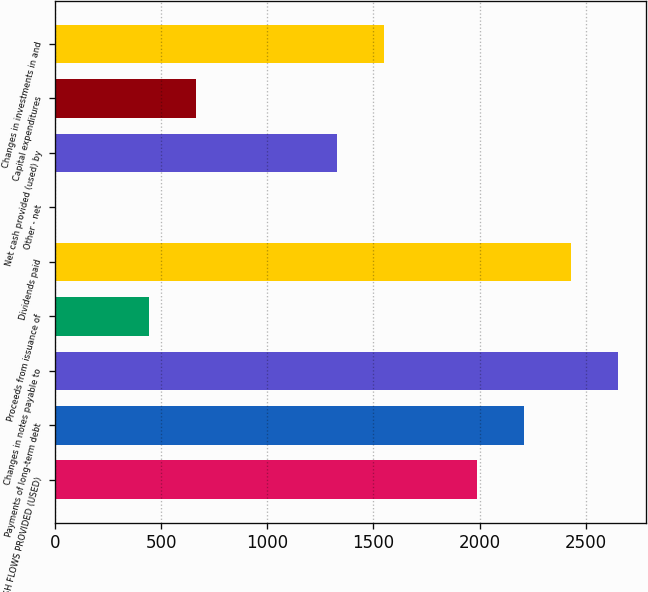Convert chart. <chart><loc_0><loc_0><loc_500><loc_500><bar_chart><fcel>NET CASH FLOWS PROVIDED (USED)<fcel>Payments of long-term debt<fcel>Changes in notes payable to<fcel>Proceeds from issuance of<fcel>Dividends paid<fcel>Other - net<fcel>Net cash provided (used) by<fcel>Capital expenditures<fcel>Changes in investments in and<nl><fcel>1990.1<fcel>2211<fcel>2652.8<fcel>443.8<fcel>2431.9<fcel>2<fcel>1327.4<fcel>664.7<fcel>1548.3<nl></chart> 